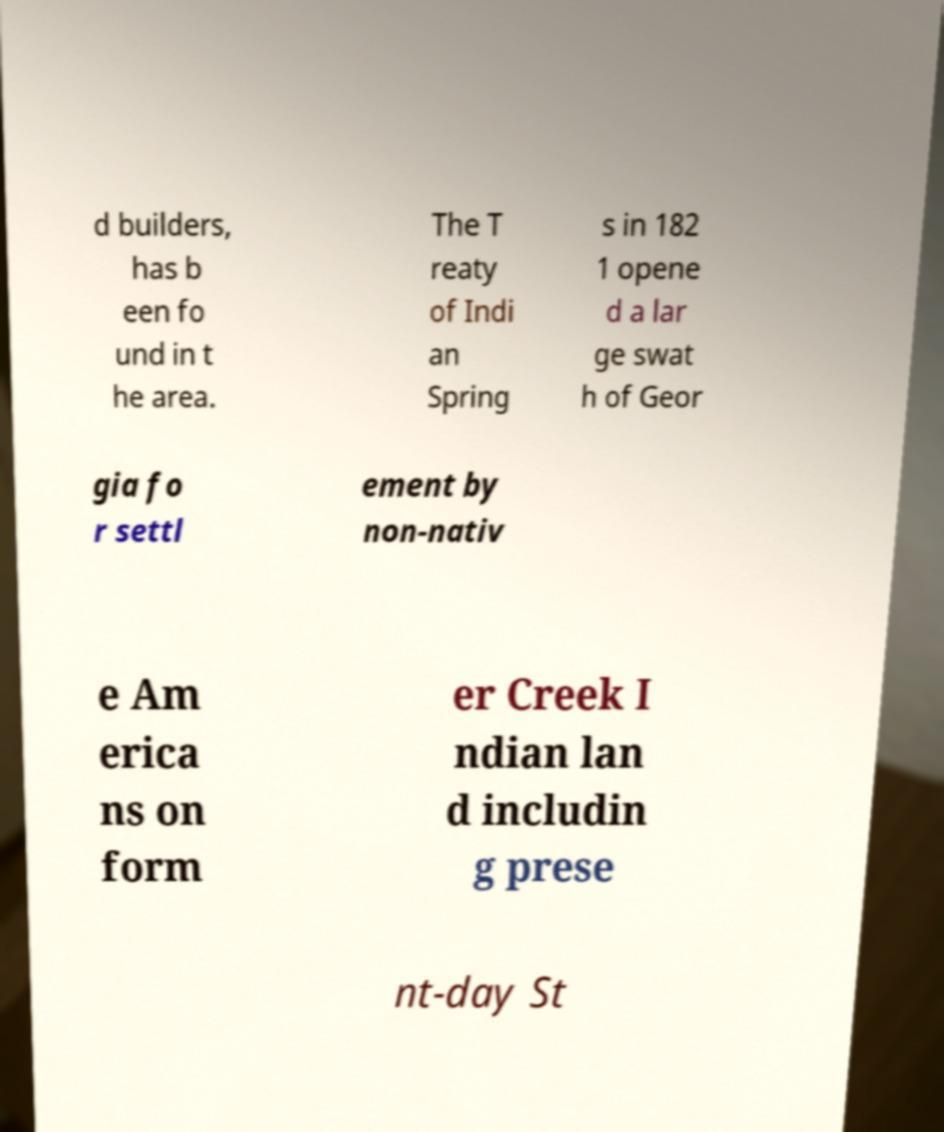What messages or text are displayed in this image? I need them in a readable, typed format. d builders, has b een fo und in t he area. The T reaty of Indi an Spring s in 182 1 opene d a lar ge swat h of Geor gia fo r settl ement by non-nativ e Am erica ns on form er Creek I ndian lan d includin g prese nt-day St 